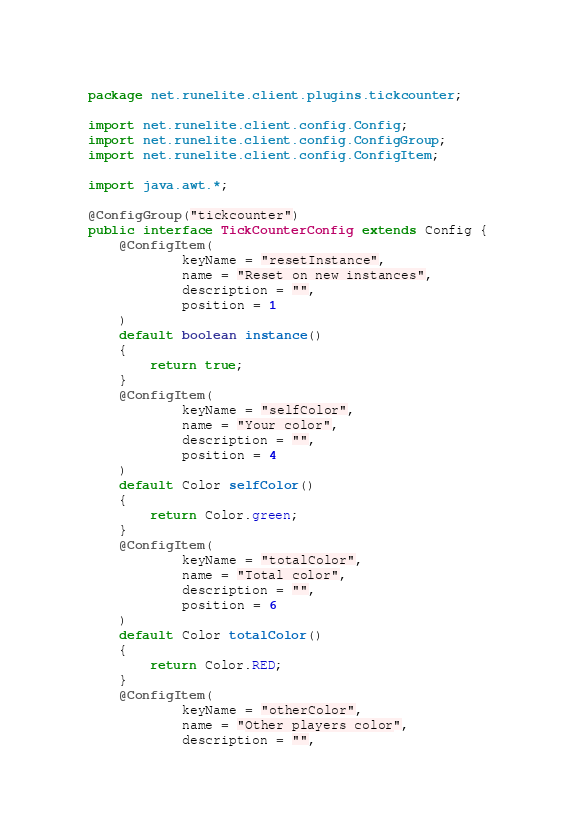<code> <loc_0><loc_0><loc_500><loc_500><_Java_>package net.runelite.client.plugins.tickcounter;

import net.runelite.client.config.Config;
import net.runelite.client.config.ConfigGroup;
import net.runelite.client.config.ConfigItem;

import java.awt.*;

@ConfigGroup("tickcounter")
public interface TickCounterConfig extends Config {
    @ConfigItem(
            keyName = "resetInstance",
            name = "Reset on new instances",
            description = "",
            position = 1
    )
    default boolean instance()
    {
        return true;
    }
    @ConfigItem(
            keyName = "selfColor",
            name = "Your color",
            description = "",
            position = 4
    )
    default Color selfColor()
    {
        return Color.green;
    }
    @ConfigItem(
            keyName = "totalColor",
            name = "Total color",
            description = "",
            position = 6
    )
    default Color totalColor()
    {
        return Color.RED;
    }
    @ConfigItem(
            keyName = "otherColor",
            name = "Other players color",
            description = "",</code> 